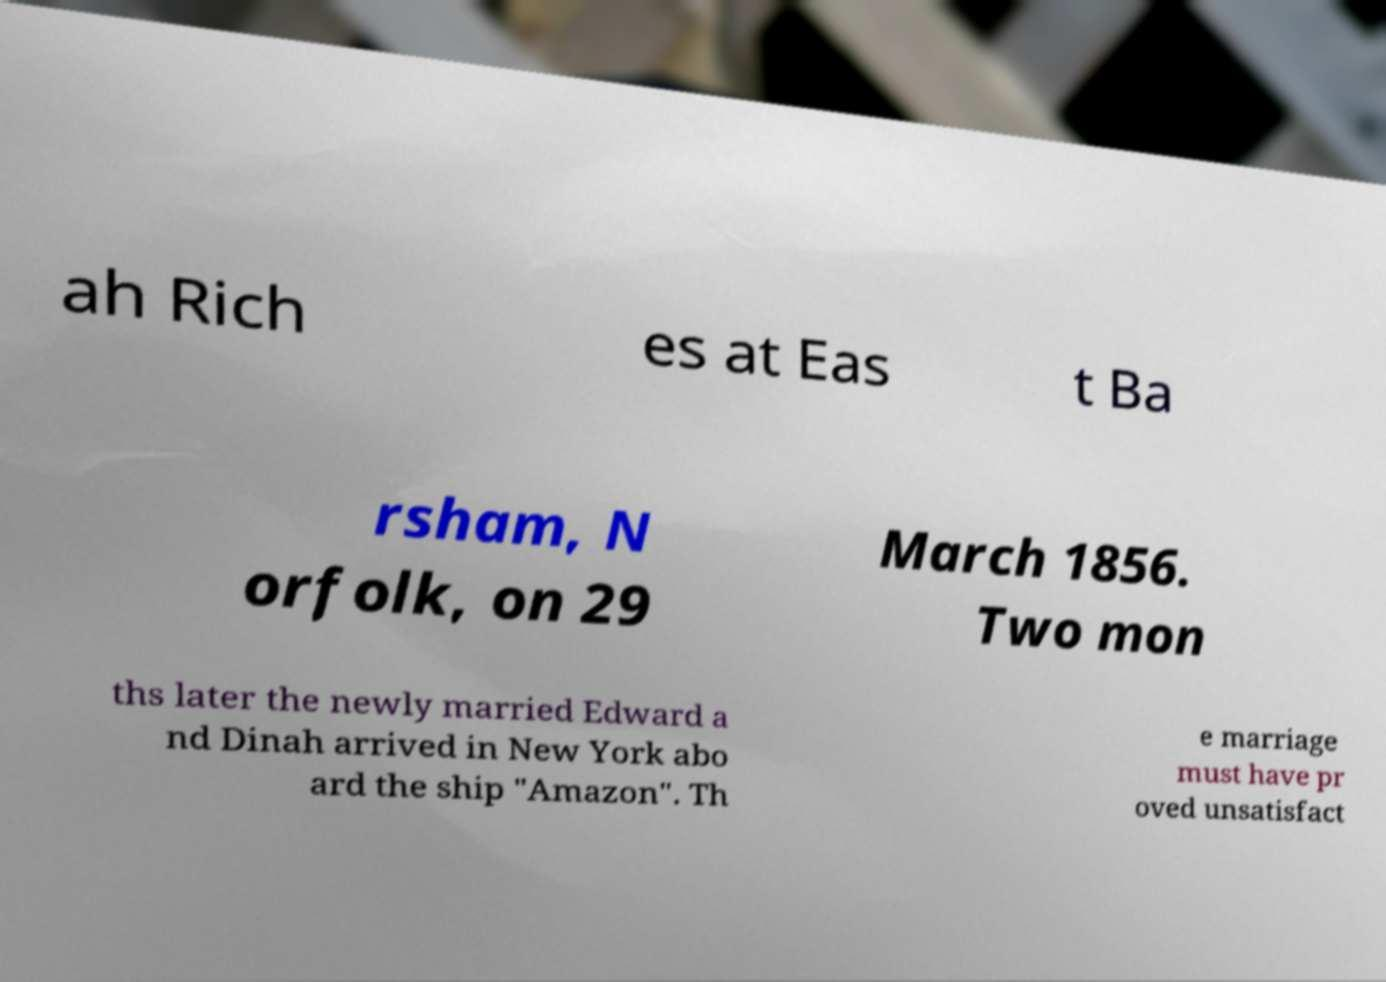What messages or text are displayed in this image? I need them in a readable, typed format. ah Rich es at Eas t Ba rsham, N orfolk, on 29 March 1856. Two mon ths later the newly married Edward a nd Dinah arrived in New York abo ard the ship "Amazon". Th e marriage must have pr oved unsatisfact 